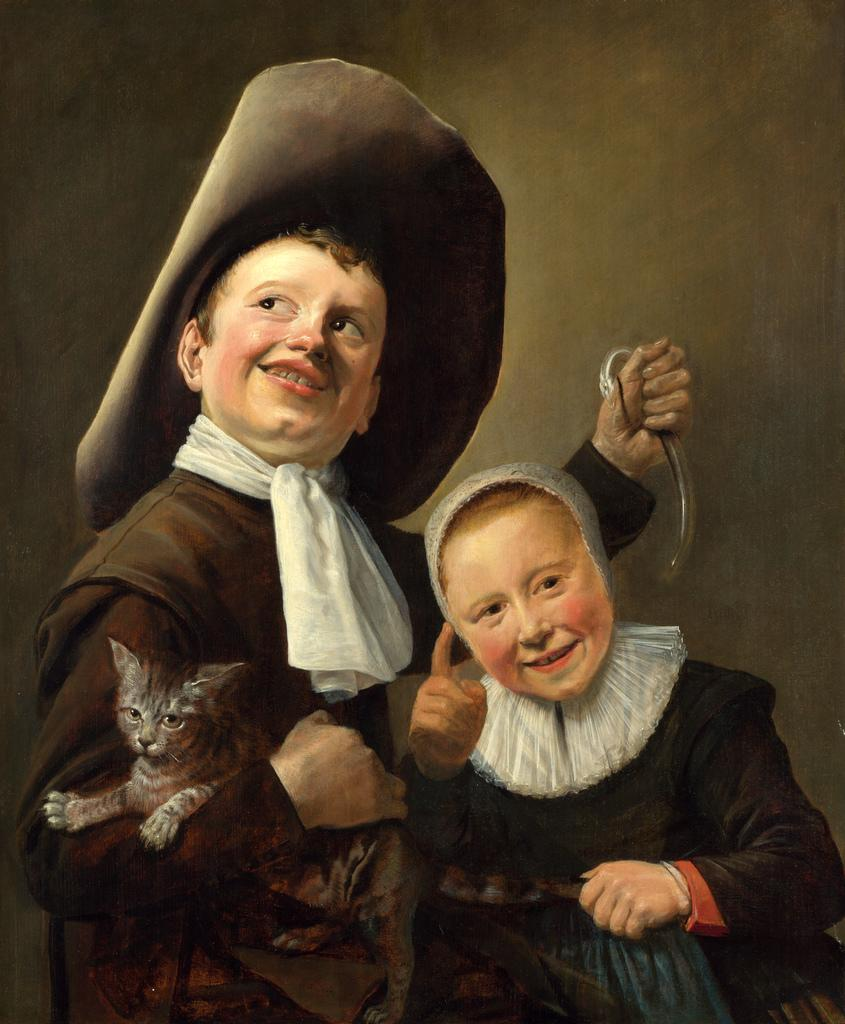What is the main subject of the image? The main subject of the image is a painting. What is happening in the painting? The painting depicts two persons, one of whom is holding a cat. What can be seen in the background of the painting? The background of the painting is brown and black in color. How many cherries are on the table in the painting? There are no cherries present in the painting; it features two persons and a cat. How many children are visible in the painting? There are no children depicted in the painting; it features two adults and a cat. 